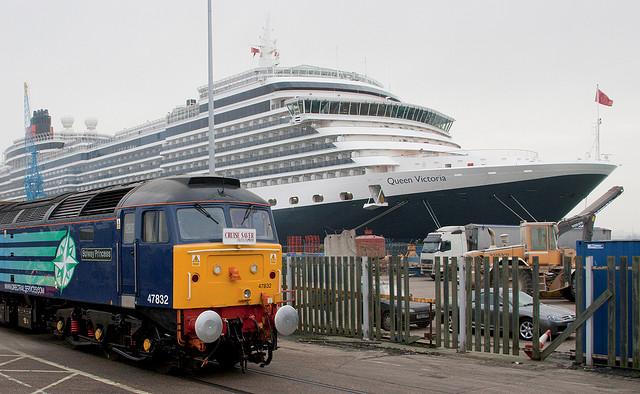What is the number on the train?
Short answer required. 47832. Is this train orange on it's front?
Be succinct. Yes. Who owns this train?
Be succinct. Cruise sister. Is the train on a track?
Be succinct. Yes. Which is larger the boat or the train?
Write a very short answer. Boat. 